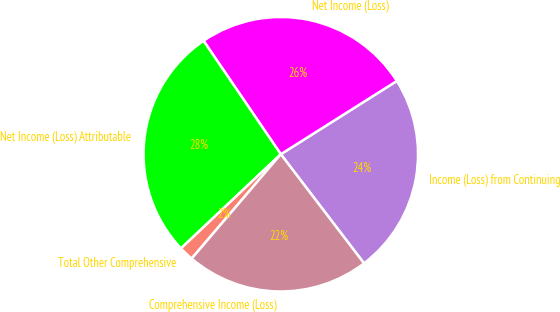<chart> <loc_0><loc_0><loc_500><loc_500><pie_chart><fcel>Income (Loss) from Continuing<fcel>Net Income (Loss)<fcel>Net Income (Loss) Attributable<fcel>Total Other Comprehensive<fcel>Comprehensive Income (Loss)<nl><fcel>23.59%<fcel>25.55%<fcel>27.52%<fcel>1.71%<fcel>21.62%<nl></chart> 